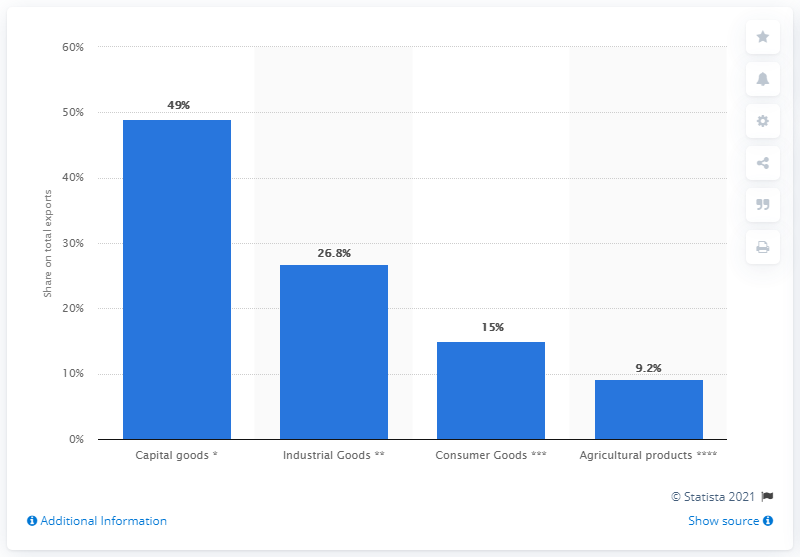Mention a couple of crucial points in this snapshot. In 2009, the share of capital goods on all exports was 49%. 